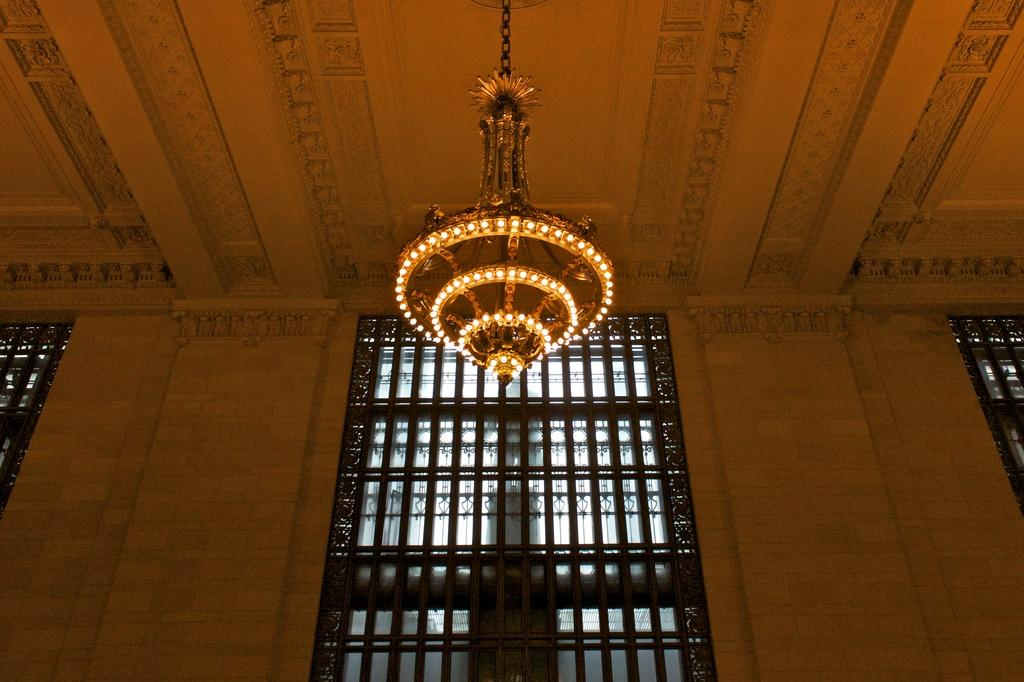What type of lighting fixture is present in the image? There is a chandelier in the image. What type of architectural feature can be seen in the image? There is a wall in the image. What allows natural light to enter the space in the image? There are windows in the image. Can you hear the drum playing in the image? There is no drum present in the image, so it is not possible to hear it playing. 